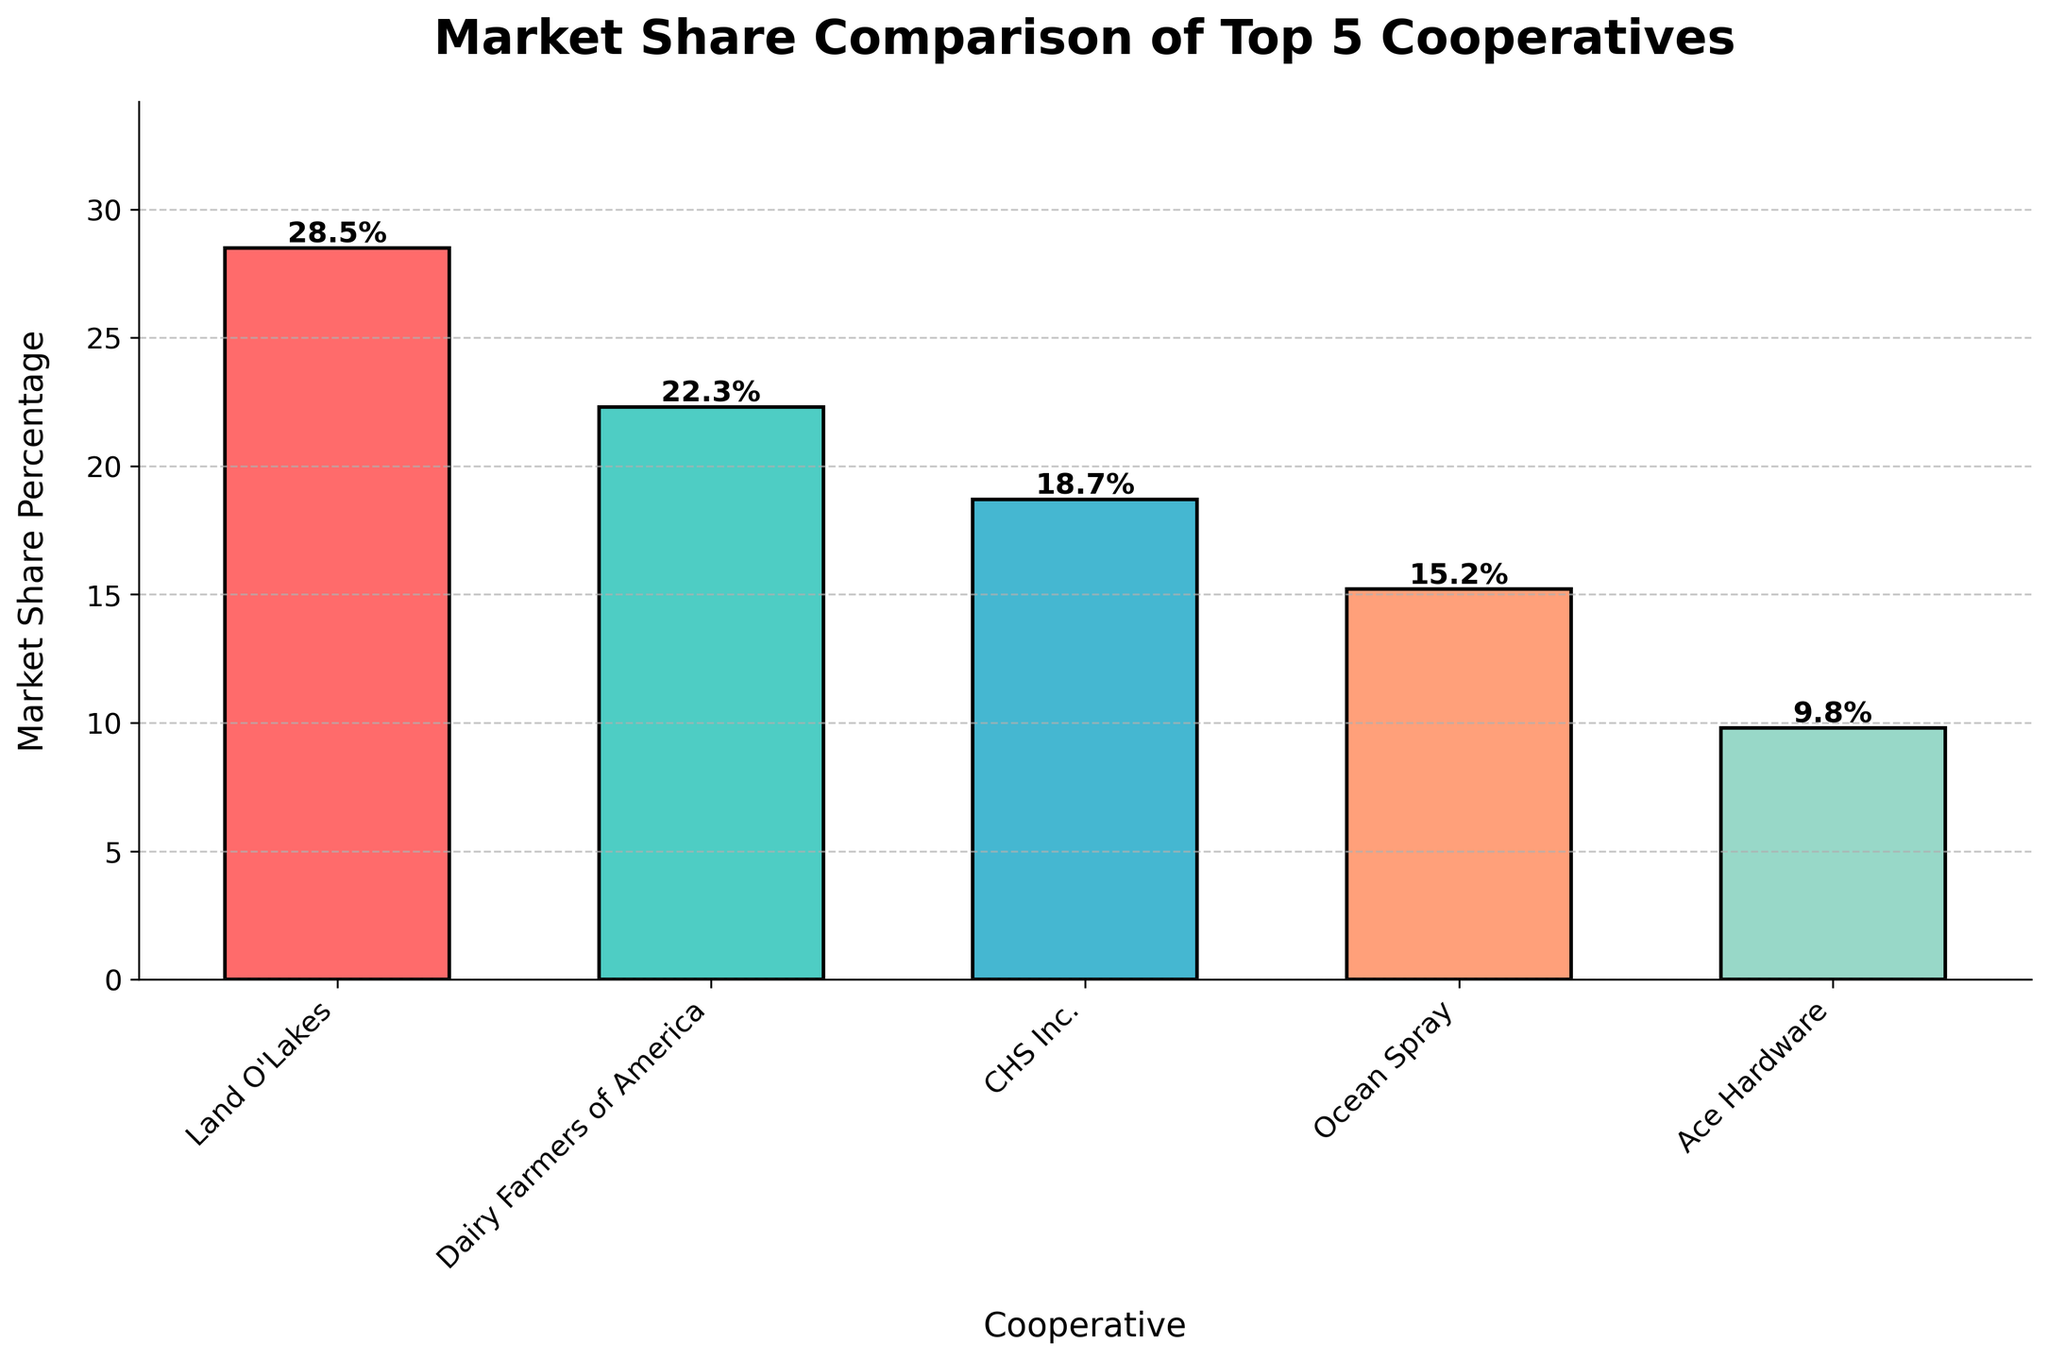What is the market share percentage of the top cooperative? The bar chart shows the market share percentages of the top 5 cooperatives. Land O'Lakes has the tallest bar with a height labeled as 28.5%, indicating it has the highest market share percentage.
Answer: 28.5% Which cooperative has the lowest market share? By observing the heights of the bars, Ace Hardware has the shortest bar with a height labeled as 9.8%, indicating it has the lowest market share among the five cooperatives.
Answer: Ace Hardware What's the difference in market share between Land O'Lakes and Dairy Farmers of America? Land O'Lakes has a market share of 28.5%, and Dairy Farmers of America has 22.3%. The difference is calculated as 28.5% - 22.3% = 6.2%.
Answer: 6.2% Which cooperative ranks third in terms of market share? The heights of the bars are compared in descending order. Land O'Lakes is first, Dairy Farmers of America is second, and CHS Inc. is third with a market share of 18.7%.
Answer: CHS Inc What is the combined market share percentage of Ocean Spray and Ace Hardware? Ocean Spray has a market share of 15.2%, and Ace Hardware has 9.8%. The combined market share is the sum: 15.2% + 9.8% = 25%.
Answer: 25% Which cooperative's bar is colored in green? By matching the bar colors with their respective cooperatives and knowing the provided color scheme, Dairy Farmers of America’s bar is colored in green.
Answer: Dairy Farmers of America Compare the market share percentages of Dairy Farmers of America and Ocean Spray. Which one is higher and by how much? Dairy Farmers of America has a market share of 22.3%, and Ocean Spray has 15.2%. Comparing them, Dairy Farmers of America's market share is higher. The difference is 22.3% - 15.2% = 7.1%.
Answer: Dairy Farmers of America, 7.1% What is the average market share percentage of these top 5 cooperatives? To find the average, first sum all market share percentages: 28.5% + 22.3% + 18.7% + 15.2% + 9.8% = 94.5%. Then, divide by the number of cooperatives, which is 5. The calculation is 94.5% / 5 = 18.9%.
Answer: 18.9% What percentage less market share does Ocean Spray have compared to CHS Inc.? CHS Inc. has a market share of 18.7%, and Ocean Spray has 15.2%. The difference is 18.7% - 15.2% = 3.5%. To express this as a percentage of CHS Inc.'s market share: (3.5 / 18.7) * 100 ≈ 18.72%.
Answer: 18.72% If the top 2 cooperatives increased their market share by 5%, what would be the new total market share percentage? Land O'Lakes and Dairy Farmers of America’s current total market share: 28.5% + 22.3% = 50.8%. Increasing each by 5%: (28.5 + 5) + (22.3 + 5) = 33.5 + 27.3 = 60.8%.
Answer: 60.8% 